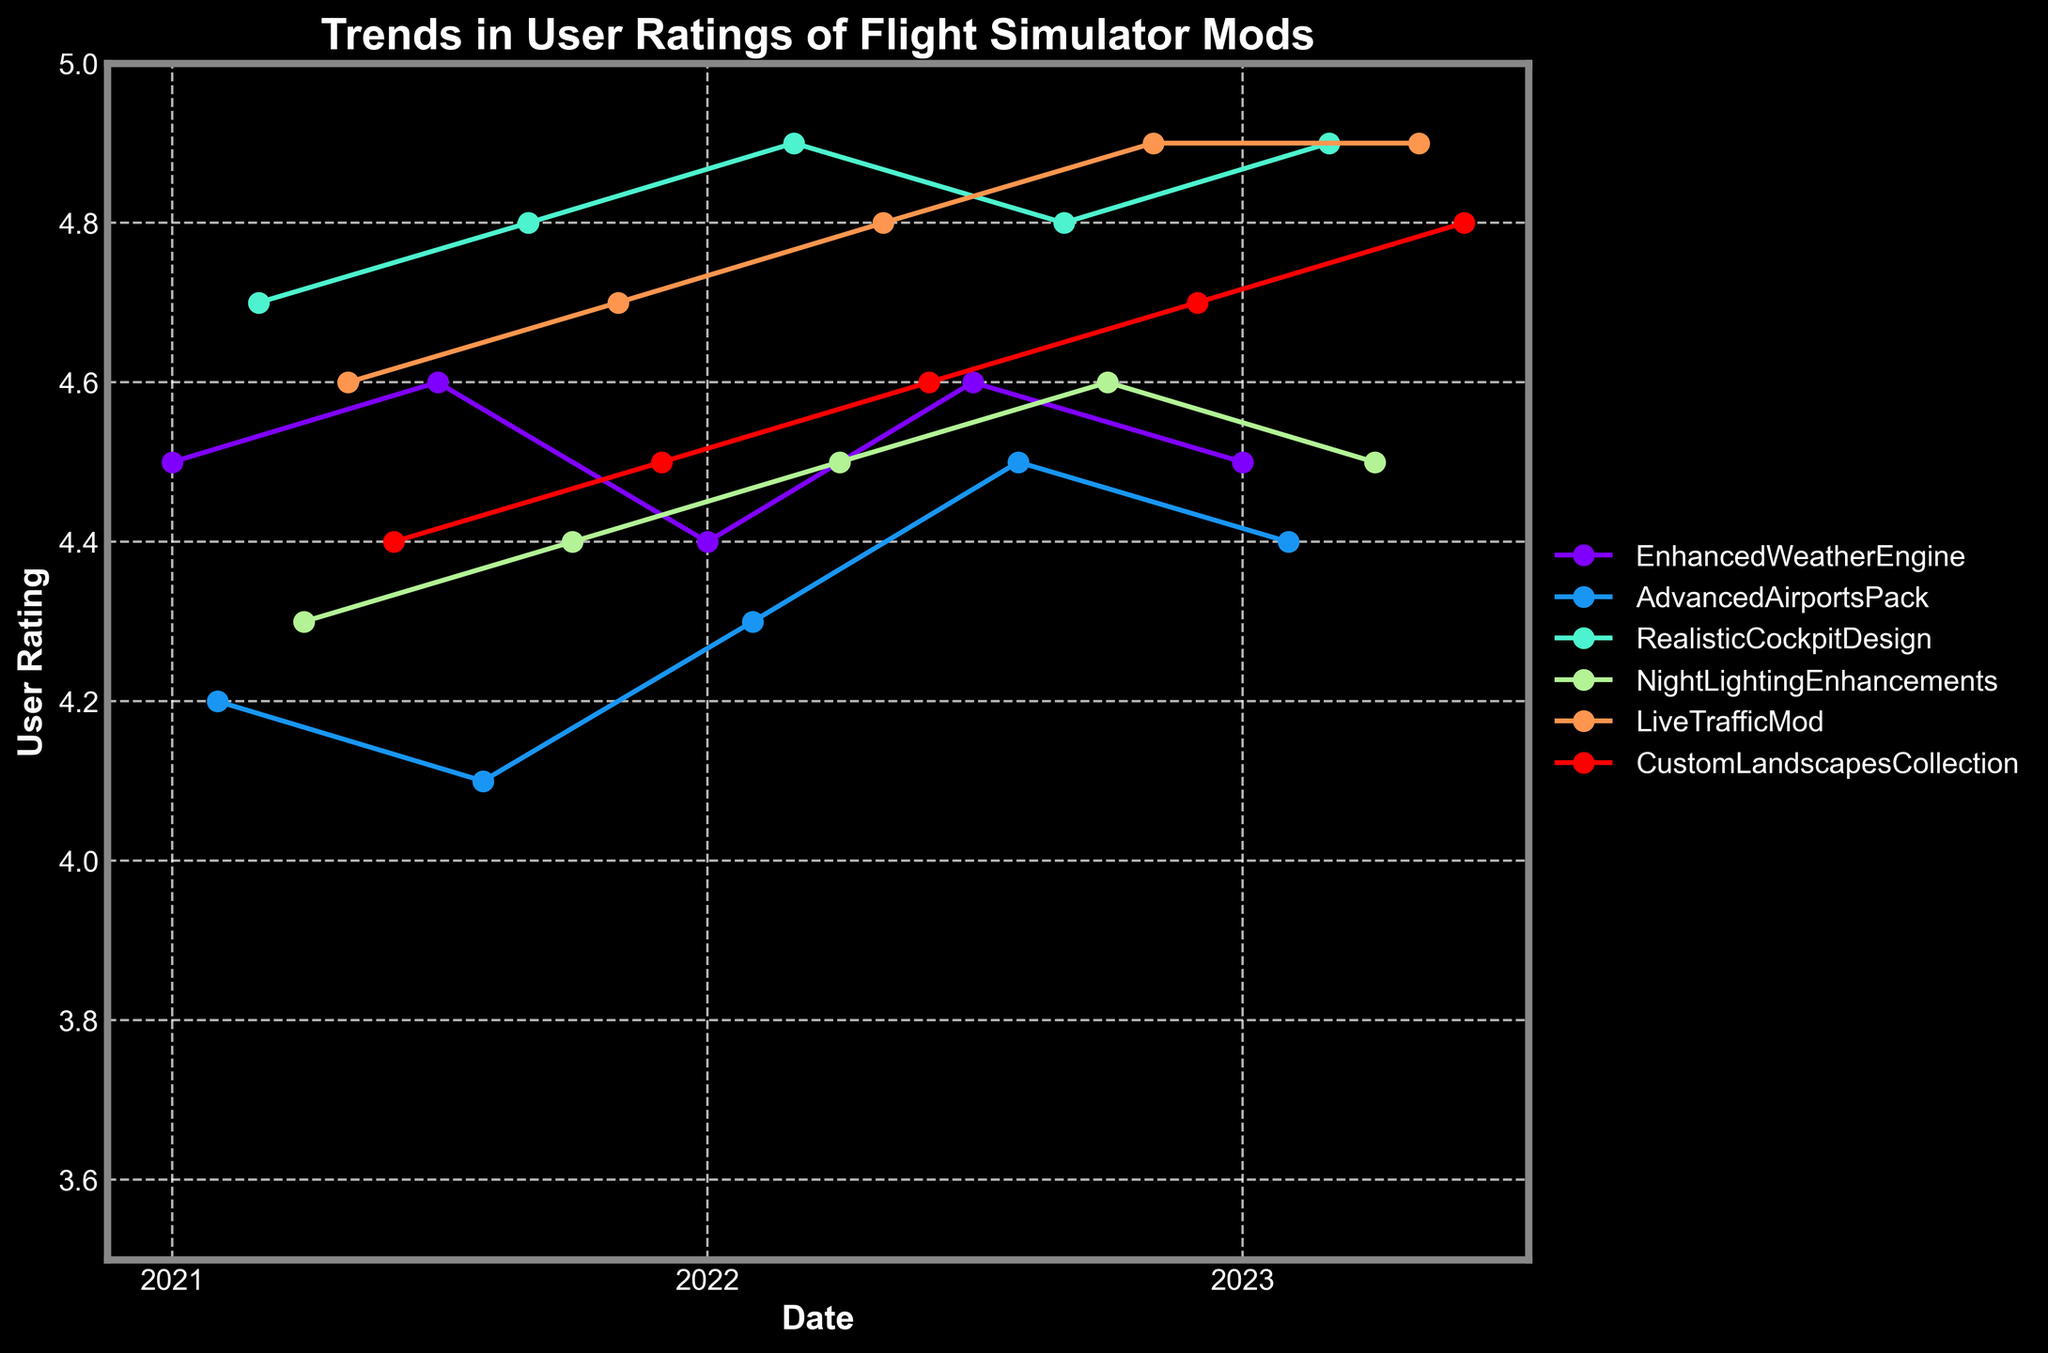What is the title of the figure? The title of the figure is found at the top and is usually bold for prominence. It describes the subject of the graph.
Answer: Trends in User Ratings of Flight Simulator Mods How many mods are displayed in the figure? The legend on the right side of the figure shows the names of all mods, each represented by a different color.
Answer: 6 What is the highest user rating in the figure and which mod achieves it? The y-axis indicates user ratings, and the highest point on the graph within the plotted lines shows the peak rating. By following that line to the legend, we can identify the mod.
Answer: 4.9, RealisticCockpitDesign Which mod shows a steady increase in user rating throughout the time period? By examining the trends in the lines, look for a mod whose ratings consistently increase or remain steady over multiple time points without a significant decrease.
Answer: LiveTrafficMod What was the user rating of the EnhancedWeatherEngine mod in July 2021? By locating the EnhancedWeatherEngine line and finding its data point at July 2021 on the x-axis, one can find the corresponding y-value.
Answer: 4.6 Which mod experienced the largest drop in user rating between two consecutive months? Analyze the plotted lines to identify any sudden downward shifts and compare the size of these drops.
Answer: AdvancedAirportsPack Has there been any mod whose user rating has never dipped below 4.5? By examining each mod's line one by one, we check for any instance where the line touches or falls below the 4.5 mark on the y-axis.
Answer: RealisticCockpitDesign How does the user rating trend for CustomLandscapesCollection from January 2021 to June 2023? Follow the line for CustomLandscapesCollection across the x-axis from January 2021 to June 2023, noting how the y-values (ratings) change over time.
Answer: Increasing trend Which mod has the most consistent user rating over the time period? Look for the line that shows the least fluctuation in y-values (ratings) across the entire time series.
Answer: NightLightingEnhancements What is the average user rating of EnhancedWeatherEngine in 2022? Locate all data points for EnhancedWeatherEngine in 2022, sum their ratings, and divide by the number of these points to find the average.
Answer: (4.4+4.6+4.5)/3 = 4.5 